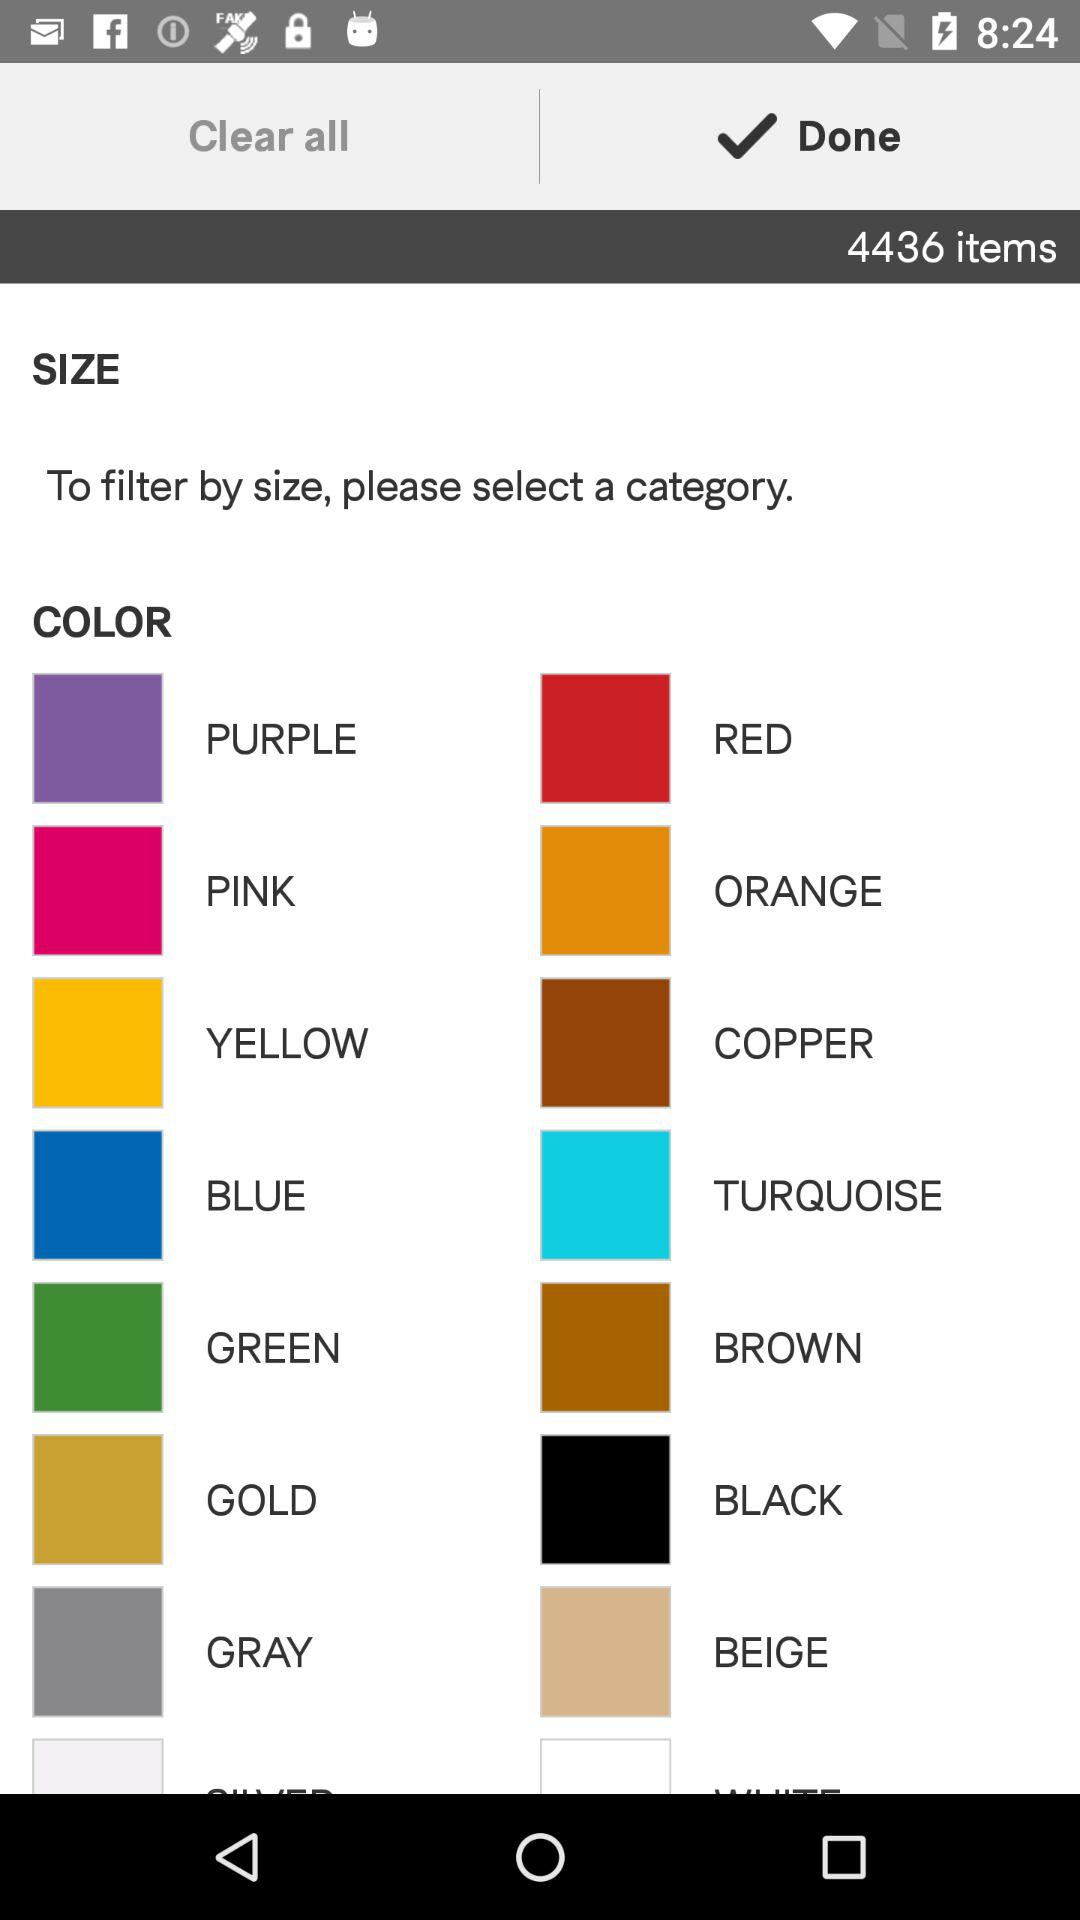How many items are there? There are 4436 items. 